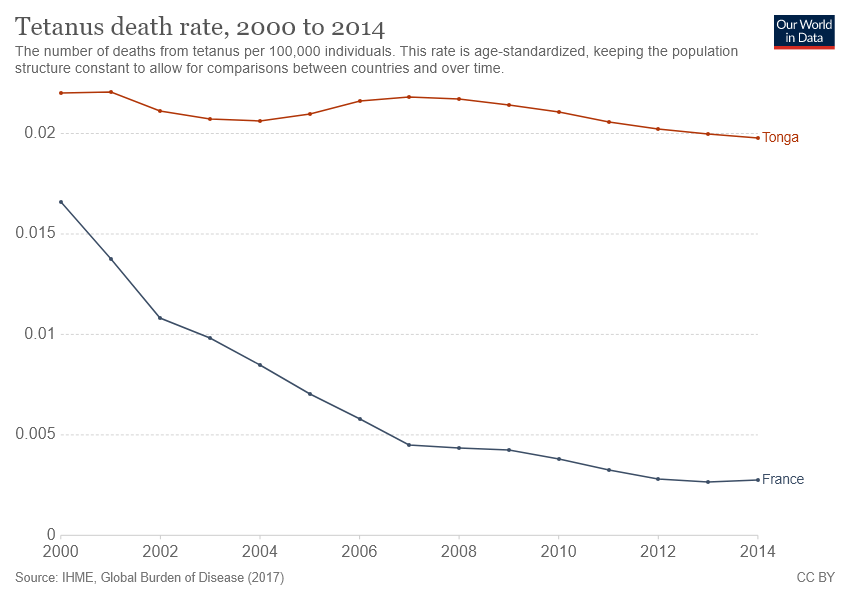List a handful of essential elements in this visual. Tetanus death rates in Tonga have historically been higher than in any other country. In 2014, France recorded the lowest death rate due to tetanus. 